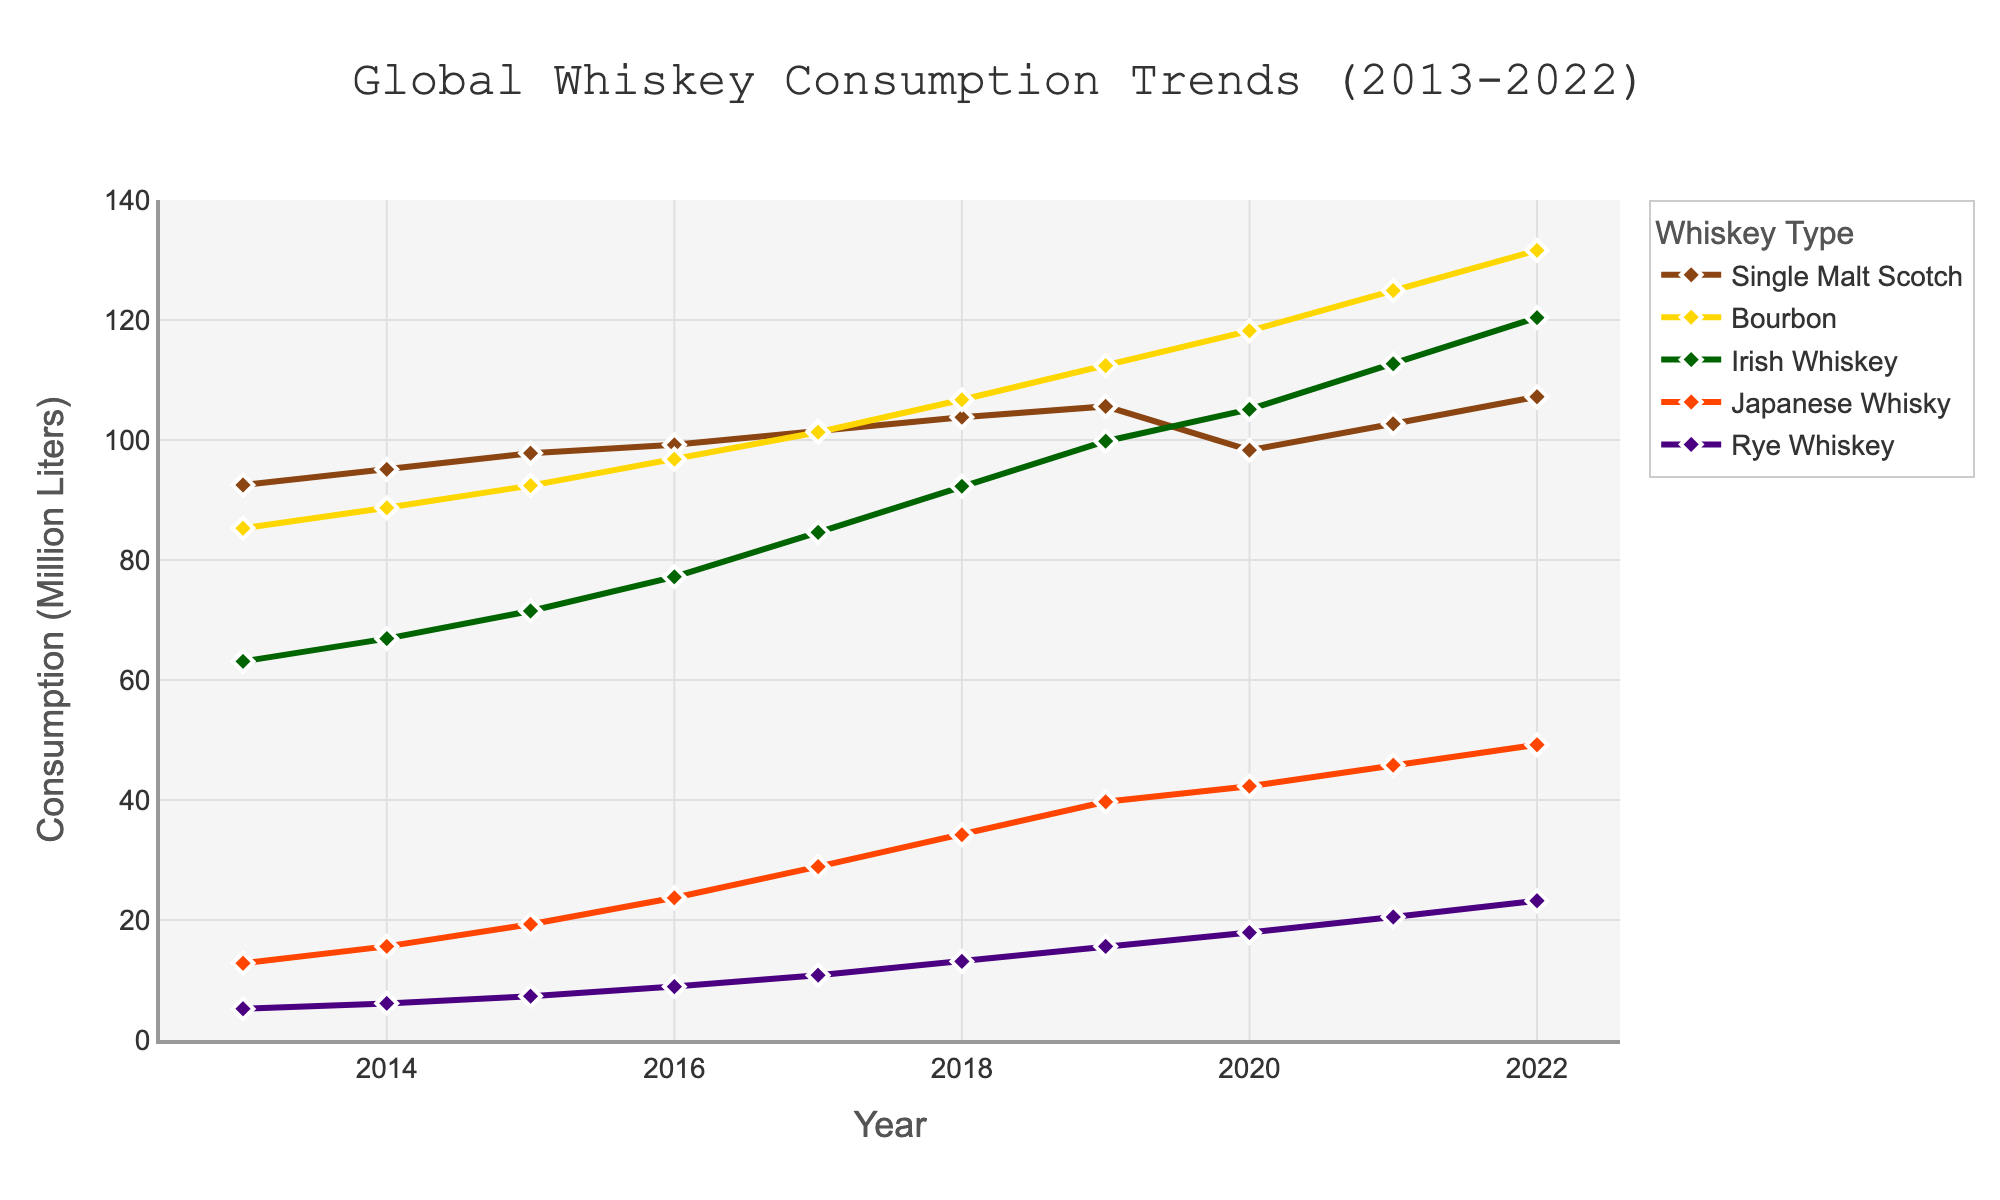What is the total global consumption of Bourbon in 2020 and 2021 combined? The consumption of Bourbon in 2020 is 118.2 million liters and in 2021 is 124.9 million liters. Adding these values: 118.2 + 124.9 = 243.1 million liters.
Answer: 243.1 million liters Between 2013 and 2022, which year had the highest consumption of Japanese Whisky? Looking at the data points for Japanese Whisky, the highest value is in 2022 with 49.2 million liters.
Answer: 2022 What is the difference in consumption of Single Malt Scotch between 2013 and the peak year? Consumption of Single Malt Scotch in 2013 is 92.5 million liters. The peak consumption is 107.2 million liters in 2022. The difference is 107.2 - 92.5 = 14.7 million liters.
Answer: 14.7 million liters Which whiskey type had the least increase in consumption from 2013 to 2022? Calculate the increase for each type: 
- Single Malt Scotch: 107.2 - 92.5 = 14.7 
- Bourbon: 131.6 - 85.3 = 46.3 
- Irish Whiskey: 120.4 - 63.1 = 57.3 
- Japanese Whisky: 49.2 - 12.8 = 36.4 
- Rye Whiskey: 23.2 - 5.2 = 18. The least increase is for Single Malt Scotch: 14.7 million liters
Answer: Single Malt Scotch How does the consumption trend of Rye Whiskey compare to Irish Whiskey from 2013 to 2022? Rye Whiskey starts at 5.2 million liters and rises to 23.2 million liters, showing a gradual increase. Irish Whiskey starts at 63.1 million liters and rises to 120.4 million liters, showing a steep increase.
Answer: Rye Whiskey has a gradual increase, while Irish Whiskey has a steep increase In which year did Bourbon consumption surpass 100 million liters? According to the data, Bourbon consumption surpassed 100 million liters in 2017 (101.3 million liters).
Answer: 2017 What is the average consumption of Rye Whiskey over the decade? To calculate the average, sum all the yearly values for Rye Whiskey and divide by the number of years: (5.2 + 6.1 + 7.3 + 8.9 + 10.8 + 13.1 + 15.6 + 17.9 + 20.5 + 23.2) / 10 = 12.86 million liters.
Answer: 12.86 million liters 